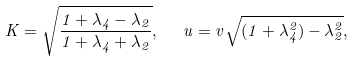<formula> <loc_0><loc_0><loc_500><loc_500>K = \sqrt { \frac { 1 + \lambda _ { 4 } - \lambda _ { 2 } } { 1 + \lambda _ { 4 } + \lambda _ { 2 } } } , \ \ u = v \sqrt { ( 1 + \lambda _ { 4 } ^ { 2 } ) - \lambda _ { 2 } ^ { 2 } } ,</formula> 